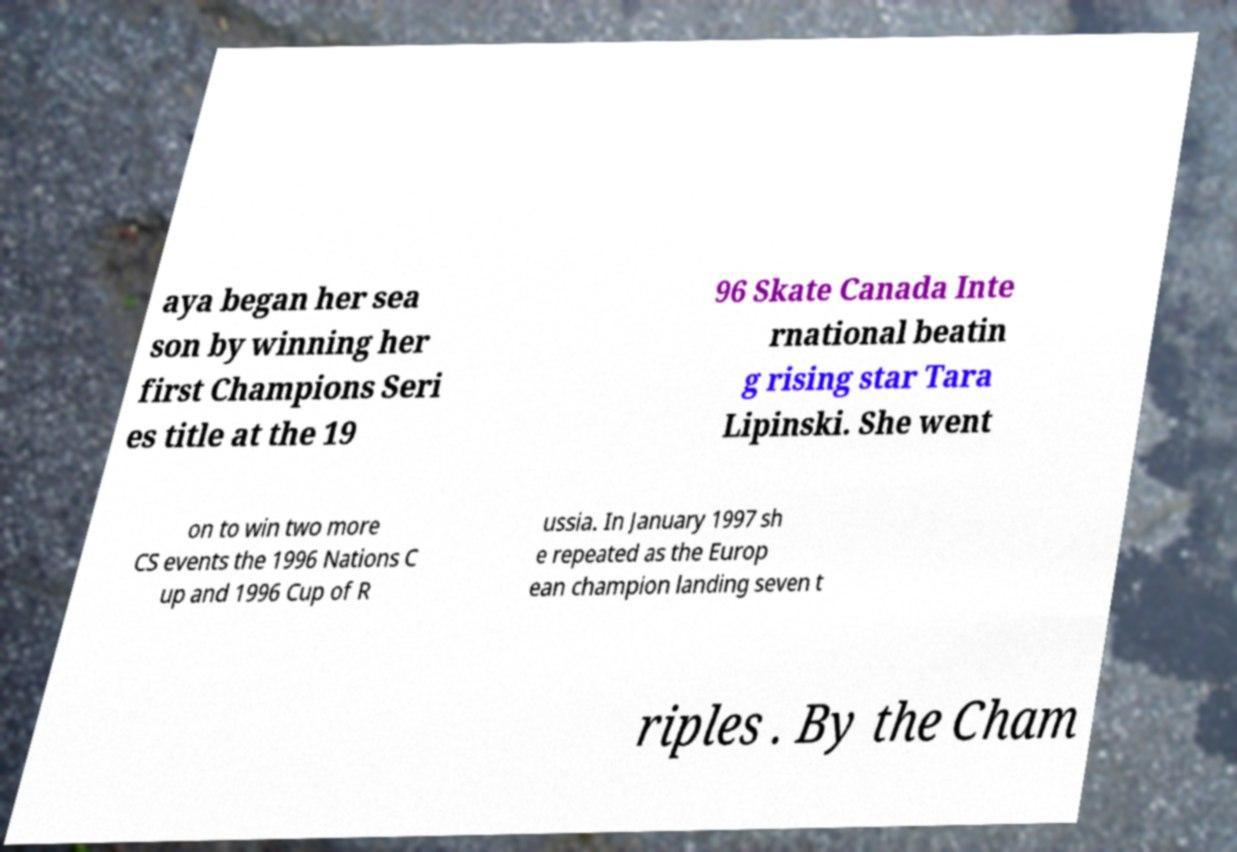Please identify and transcribe the text found in this image. aya began her sea son by winning her first Champions Seri es title at the 19 96 Skate Canada Inte rnational beatin g rising star Tara Lipinski. She went on to win two more CS events the 1996 Nations C up and 1996 Cup of R ussia. In January 1997 sh e repeated as the Europ ean champion landing seven t riples . By the Cham 